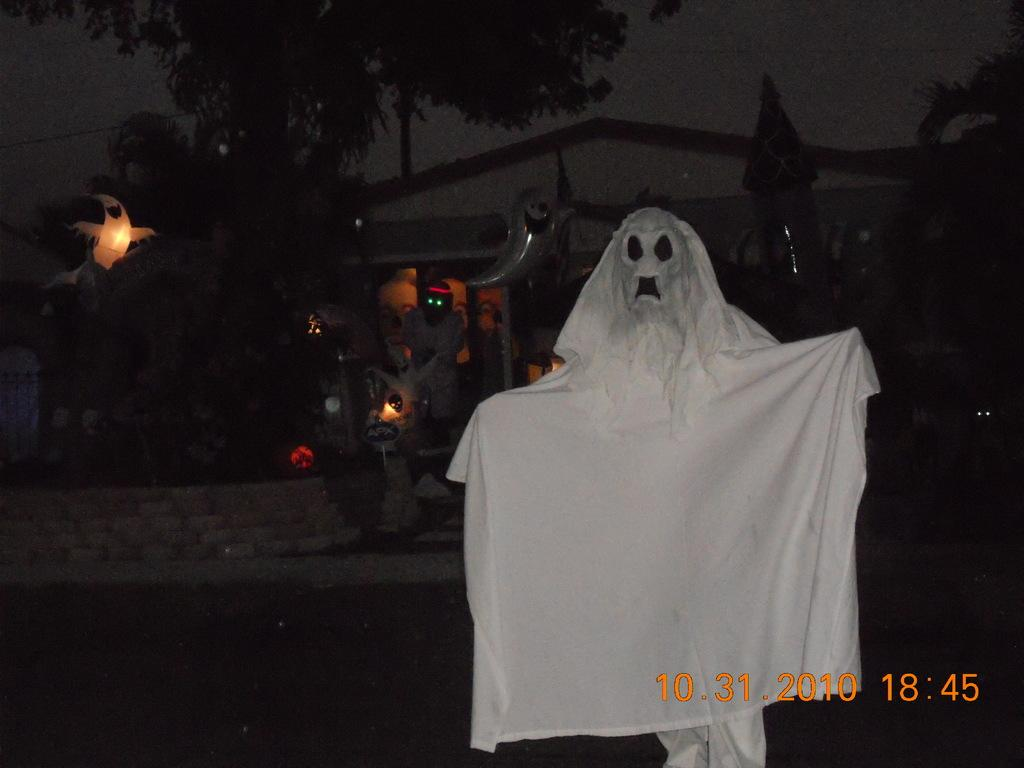What type of costume is in the image? There is a devil costume in the image. What can be seen in the background of the image? There is a tree in the background of the image. What else is visible in the image besides the costume and tree? There are lights visible in the image. What type of fruit is hanging from the devil costume in the image? There is no fruit present in the image, and it is not hanging from the devil costume. 